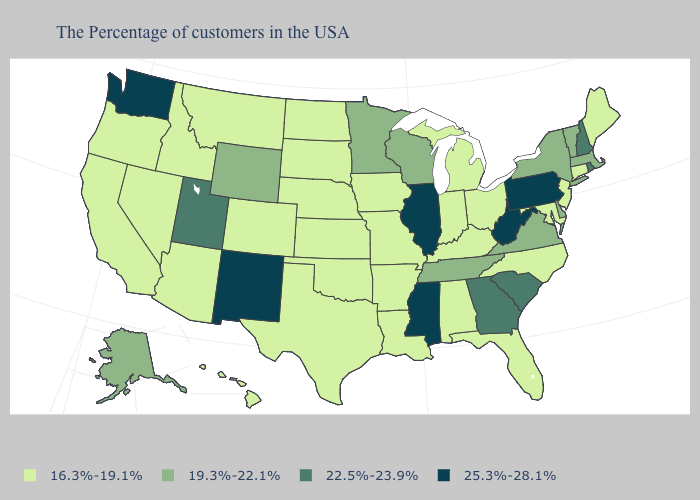Name the states that have a value in the range 16.3%-19.1%?
Quick response, please. Maine, Connecticut, New Jersey, Maryland, North Carolina, Ohio, Florida, Michigan, Kentucky, Indiana, Alabama, Louisiana, Missouri, Arkansas, Iowa, Kansas, Nebraska, Oklahoma, Texas, South Dakota, North Dakota, Colorado, Montana, Arizona, Idaho, Nevada, California, Oregon, Hawaii. Name the states that have a value in the range 16.3%-19.1%?
Answer briefly. Maine, Connecticut, New Jersey, Maryland, North Carolina, Ohio, Florida, Michigan, Kentucky, Indiana, Alabama, Louisiana, Missouri, Arkansas, Iowa, Kansas, Nebraska, Oklahoma, Texas, South Dakota, North Dakota, Colorado, Montana, Arizona, Idaho, Nevada, California, Oregon, Hawaii. Name the states that have a value in the range 16.3%-19.1%?
Quick response, please. Maine, Connecticut, New Jersey, Maryland, North Carolina, Ohio, Florida, Michigan, Kentucky, Indiana, Alabama, Louisiana, Missouri, Arkansas, Iowa, Kansas, Nebraska, Oklahoma, Texas, South Dakota, North Dakota, Colorado, Montana, Arizona, Idaho, Nevada, California, Oregon, Hawaii. Name the states that have a value in the range 19.3%-22.1%?
Short answer required. Massachusetts, Vermont, New York, Delaware, Virginia, Tennessee, Wisconsin, Minnesota, Wyoming, Alaska. Among the states that border Oklahoma , which have the highest value?
Quick response, please. New Mexico. Does Mississippi have the highest value in the USA?
Answer briefly. Yes. What is the value of Arizona?
Give a very brief answer. 16.3%-19.1%. Among the states that border Iowa , which have the highest value?
Write a very short answer. Illinois. Does Virginia have a lower value than New York?
Quick response, please. No. Name the states that have a value in the range 19.3%-22.1%?
Short answer required. Massachusetts, Vermont, New York, Delaware, Virginia, Tennessee, Wisconsin, Minnesota, Wyoming, Alaska. Does Connecticut have a lower value than Mississippi?
Give a very brief answer. Yes. Name the states that have a value in the range 22.5%-23.9%?
Be succinct. Rhode Island, New Hampshire, South Carolina, Georgia, Utah. Does the first symbol in the legend represent the smallest category?
Keep it brief. Yes. What is the highest value in states that border West Virginia?
Quick response, please. 25.3%-28.1%. Does the first symbol in the legend represent the smallest category?
Be succinct. Yes. 